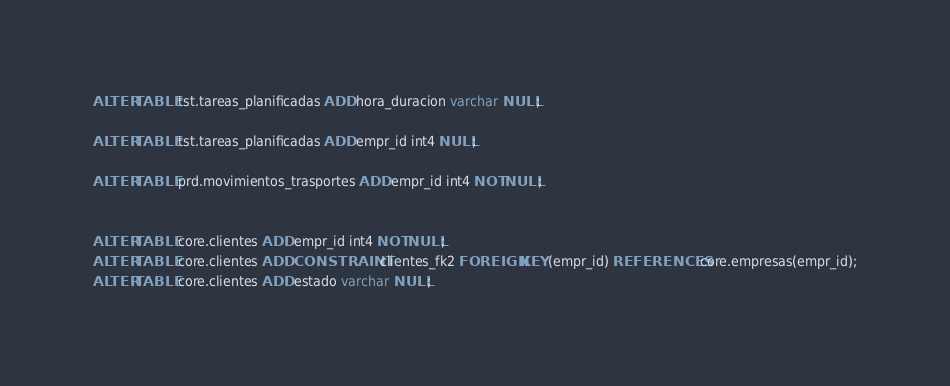<code> <loc_0><loc_0><loc_500><loc_500><_SQL_>ALTER TABLE tst.tareas_planificadas ADD hora_duracion varchar NULL;

ALTER TABLE tst.tareas_planificadas ADD empr_id int4 NULL;

ALTER TABLE prd.movimientos_trasportes ADD empr_id int4 NOT NULL;


ALTER TABLE core.clientes ADD empr_id int4 NOT NULL;
ALTER TABLE core.clientes ADD CONSTRAINT clientes_fk2 FOREIGN KEY (empr_id) REFERENCES core.empresas(empr_id);
ALTER TABLE core.clientes ADD estado varchar NULL;</code> 